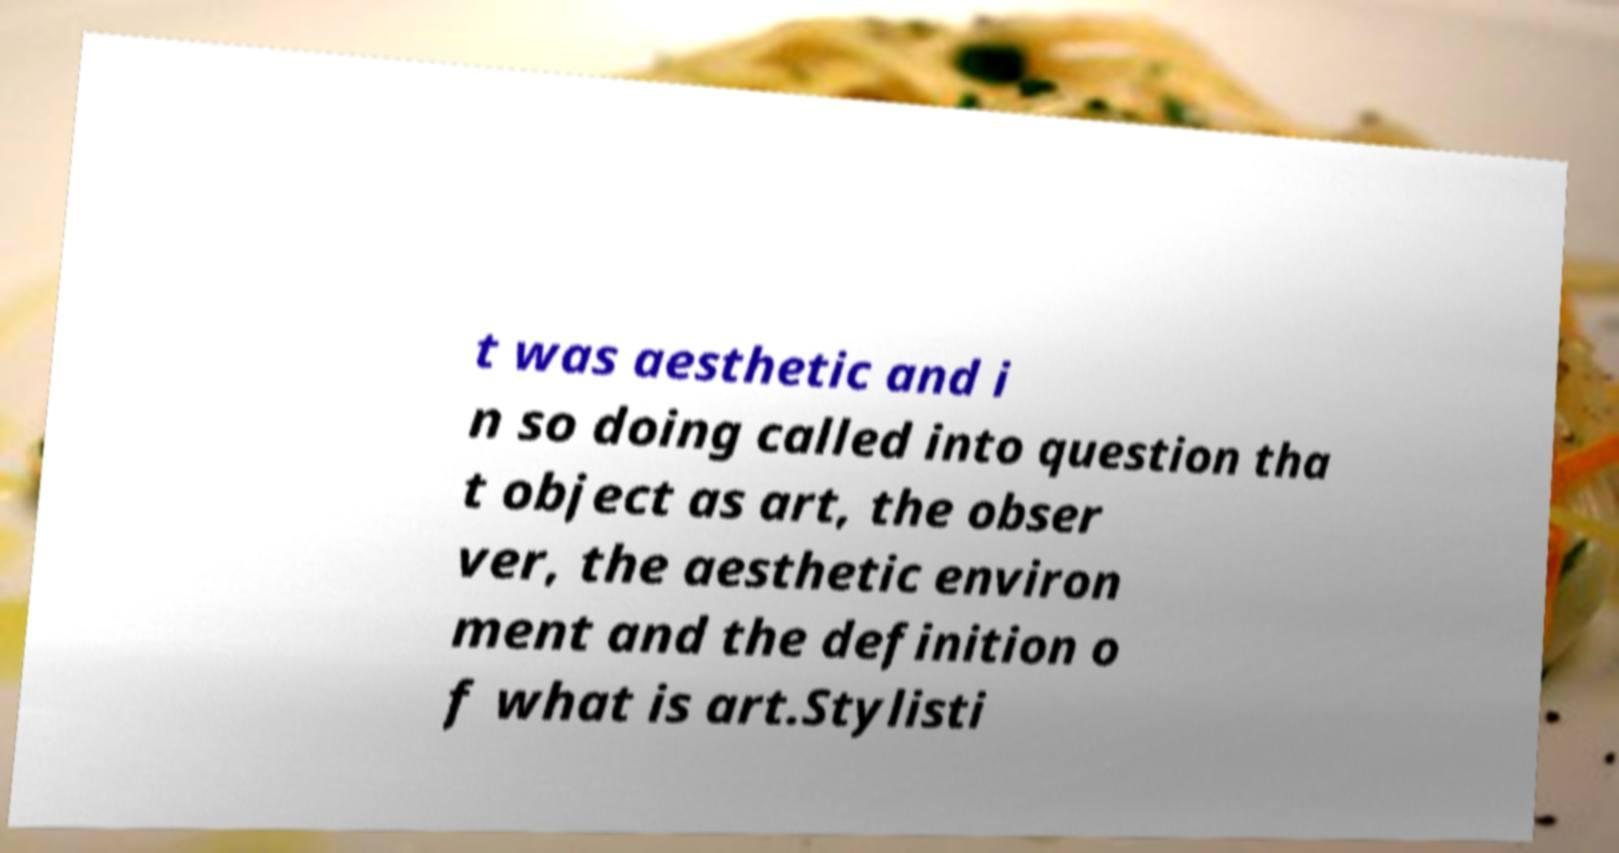Can you read and provide the text displayed in the image?This photo seems to have some interesting text. Can you extract and type it out for me? t was aesthetic and i n so doing called into question tha t object as art, the obser ver, the aesthetic environ ment and the definition o f what is art.Stylisti 